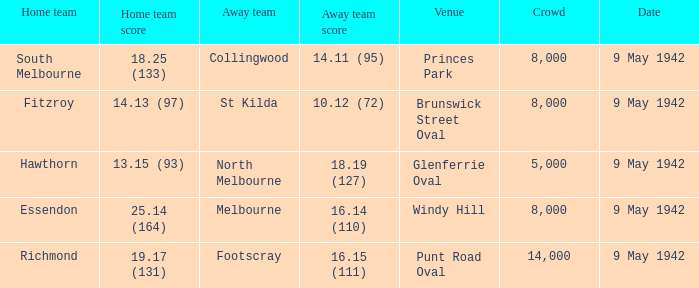How large was the crowd with a home team score of 18.25 (133)? 8000.0. 